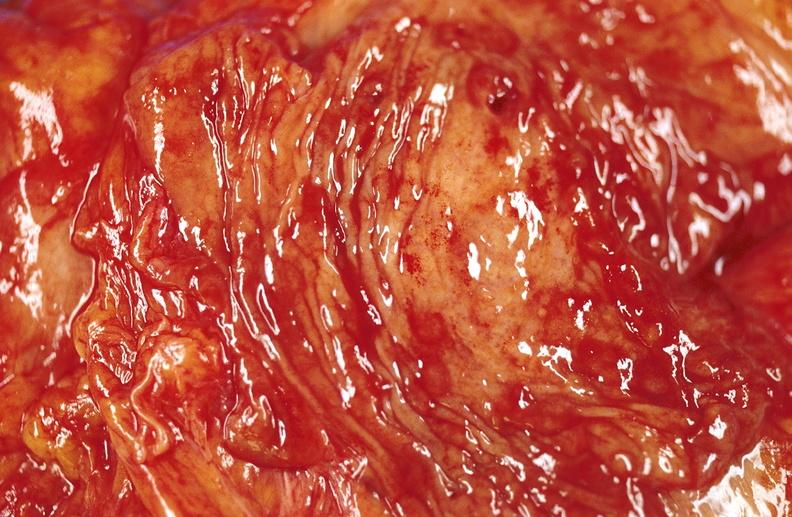does this image show duodenal ulcer?
Answer the question using a single word or phrase. Yes 